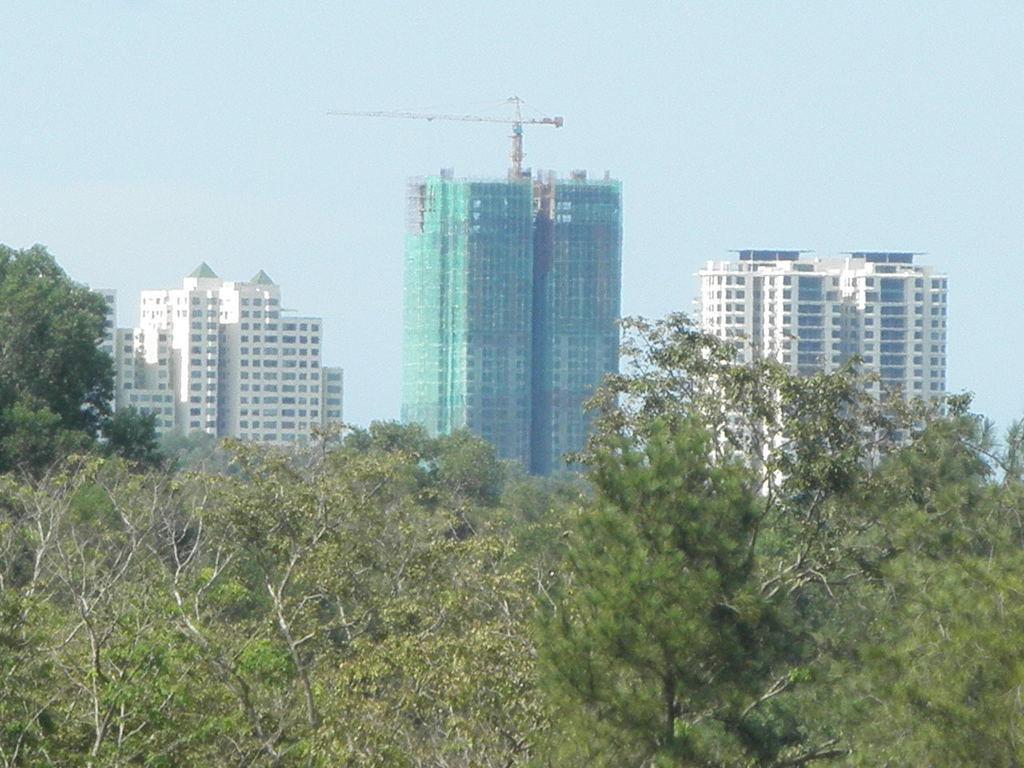In one or two sentences, can you explain what this image depicts? This picture shows few buildings and we see few trees and a cloudy sky. 